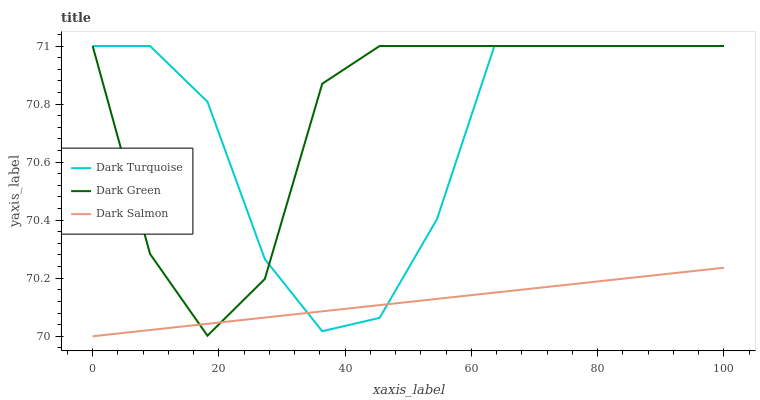Does Dark Salmon have the minimum area under the curve?
Answer yes or no. Yes. Does Dark Green have the maximum area under the curve?
Answer yes or no. Yes. Does Dark Green have the minimum area under the curve?
Answer yes or no. No. Does Dark Salmon have the maximum area under the curve?
Answer yes or no. No. Is Dark Salmon the smoothest?
Answer yes or no. Yes. Is Dark Turquoise the roughest?
Answer yes or no. Yes. Is Dark Green the smoothest?
Answer yes or no. No. Is Dark Green the roughest?
Answer yes or no. No. Does Dark Salmon have the lowest value?
Answer yes or no. Yes. Does Dark Green have the lowest value?
Answer yes or no. No. Does Dark Green have the highest value?
Answer yes or no. Yes. Does Dark Salmon have the highest value?
Answer yes or no. No. Does Dark Green intersect Dark Salmon?
Answer yes or no. Yes. Is Dark Green less than Dark Salmon?
Answer yes or no. No. Is Dark Green greater than Dark Salmon?
Answer yes or no. No. 